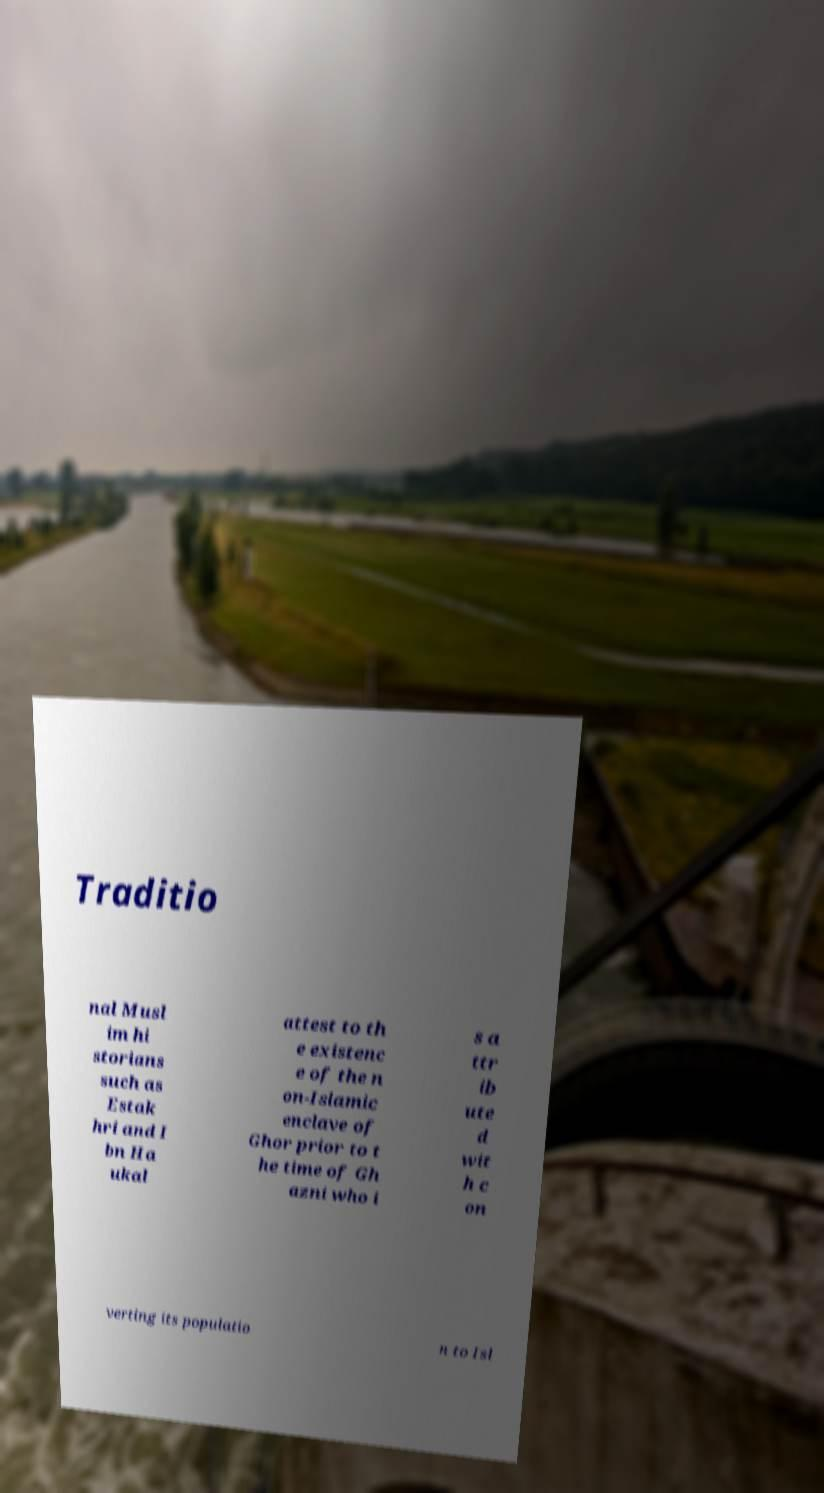There's text embedded in this image that I need extracted. Can you transcribe it verbatim? Traditio nal Musl im hi storians such as Estak hri and I bn Ha ukal attest to th e existenc e of the n on-Islamic enclave of Ghor prior to t he time of Gh azni who i s a ttr ib ute d wit h c on verting its populatio n to Isl 